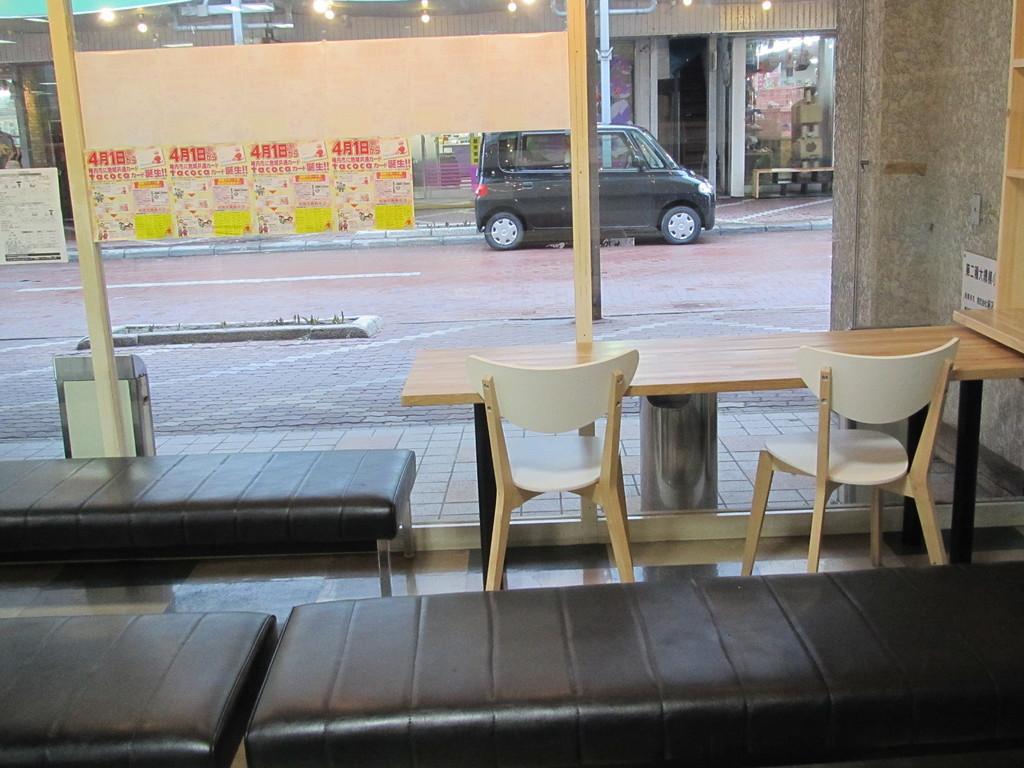Can you describe this image briefly? In the center of the image there are tables and chairs. We can see benches. In the background there is a vehicle and we can see a shed. At the top there are lights. 